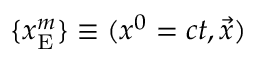Convert formula to latex. <formula><loc_0><loc_0><loc_500><loc_500>\{ x _ { E } ^ { m } \} \equiv ( x ^ { 0 } = c t , { \vec { x } } )</formula> 